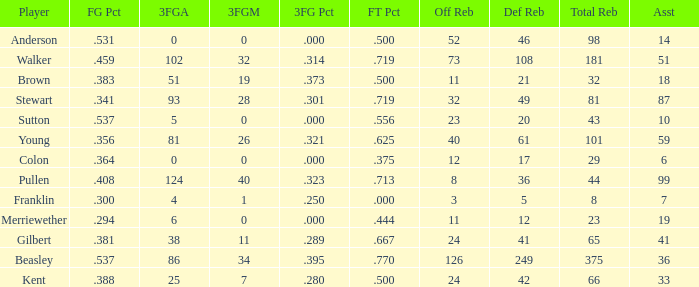What is the total number of offensive rebounds for players with more than 124 3-point attempts? 0.0. 